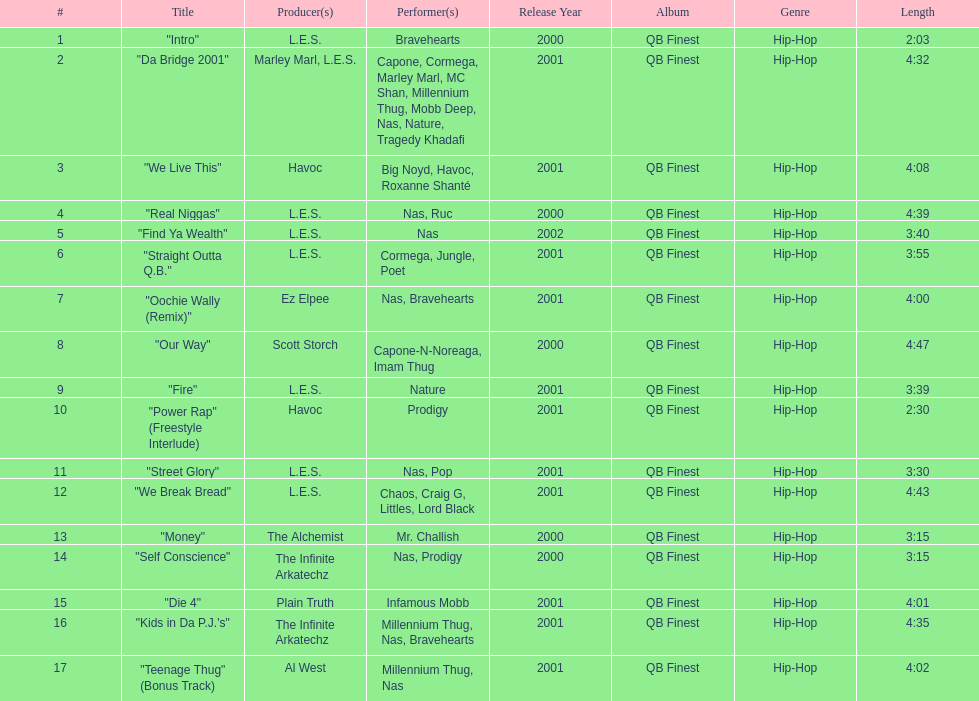How many minutes does the shortest song on the album last? 2:03. Could you help me parse every detail presented in this table? {'header': ['#', 'Title', 'Producer(s)', 'Performer(s)', 'Release Year', 'Album', 'Genre', 'Length'], 'rows': [['1', '"Intro"', 'L.E.S.', 'Bravehearts', '2000', 'QB Finest', 'Hip-Hop', '2:03'], ['2', '"Da Bridge 2001"', 'Marley Marl, L.E.S.', 'Capone, Cormega, Marley Marl, MC Shan, Millennium Thug, Mobb Deep, Nas, Nature, Tragedy Khadafi', '2001', 'QB Finest', 'Hip-Hop', '4:32'], ['3', '"We Live This"', 'Havoc', 'Big Noyd, Havoc, Roxanne Shanté', '2001', 'QB Finest', 'Hip-Hop', '4:08'], ['4', '"Real Niggas"', 'L.E.S.', 'Nas, Ruc', '2000', 'QB Finest', 'Hip-Hop', '4:39'], ['5', '"Find Ya Wealth"', 'L.E.S.', 'Nas', '2002', 'QB Finest', 'Hip-Hop', '3:40'], ['6', '"Straight Outta Q.B."', 'L.E.S.', 'Cormega, Jungle, Poet', '2001', 'QB Finest', 'Hip-Hop', '3:55'], ['7', '"Oochie Wally (Remix)"', 'Ez Elpee', 'Nas, Bravehearts', '2001', 'QB Finest', 'Hip-Hop', '4:00'], ['8', '"Our Way"', 'Scott Storch', 'Capone-N-Noreaga, Imam Thug', '2000', 'QB Finest', 'Hip-Hop', '4:47'], ['9', '"Fire"', 'L.E.S.', 'Nature', '2001', 'QB Finest', 'Hip-Hop', '3:39'], ['10', '"Power Rap" (Freestyle Interlude)', 'Havoc', 'Prodigy', '2001', 'QB Finest', 'Hip-Hop', '2:30'], ['11', '"Street Glory"', 'L.E.S.', 'Nas, Pop', '2001', 'QB Finest', 'Hip-Hop', '3:30'], ['12', '"We Break Bread"', 'L.E.S.', 'Chaos, Craig G, Littles, Lord Black', '2001', 'QB Finest', 'Hip-Hop', '4:43'], ['13', '"Money"', 'The Alchemist', 'Mr. Challish', '2000', 'QB Finest', 'Hip-Hop', '3:15'], ['14', '"Self Conscience"', 'The Infinite Arkatechz', 'Nas, Prodigy', '2000', 'QB Finest', 'Hip-Hop', '3:15'], ['15', '"Die 4"', 'Plain Truth', 'Infamous Mobb', '2001', 'QB Finest', 'Hip-Hop', '4:01'], ['16', '"Kids in Da P.J.\'s"', 'The Infinite Arkatechz', 'Millennium Thug, Nas, Bravehearts', '2001', 'QB Finest', 'Hip-Hop', '4:35'], ['17', '"Teenage Thug" (Bonus Track)', 'Al West', 'Millennium Thug, Nas', '2001', 'QB Finest', 'Hip-Hop', '4:02']]} 